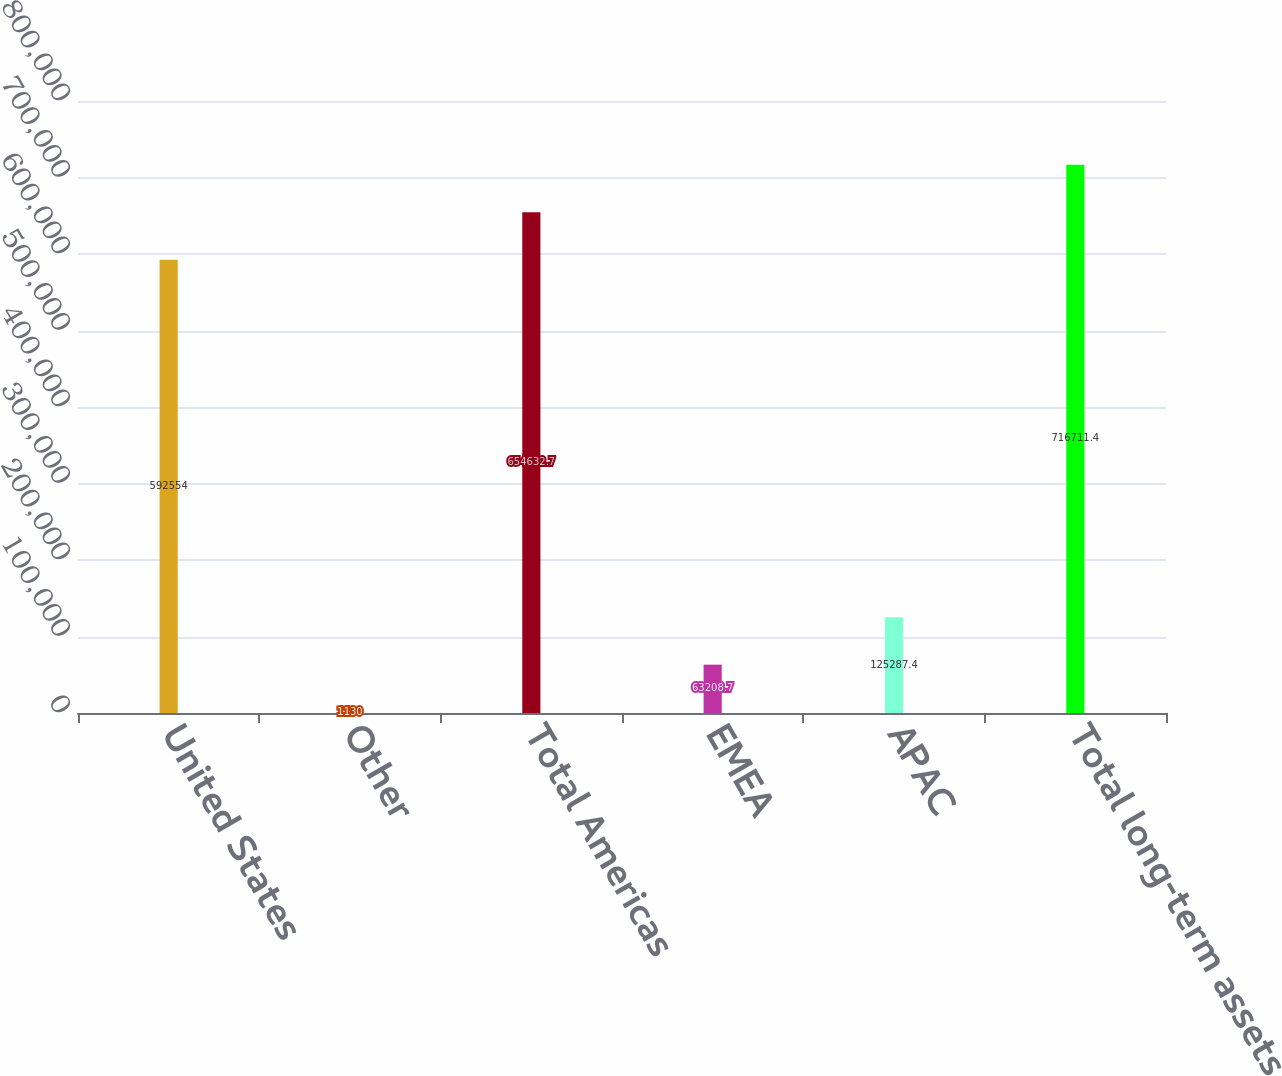Convert chart to OTSL. <chart><loc_0><loc_0><loc_500><loc_500><bar_chart><fcel>United States<fcel>Other<fcel>Total Americas<fcel>EMEA<fcel>APAC<fcel>Total long-term assets<nl><fcel>592554<fcel>1130<fcel>654633<fcel>63208.7<fcel>125287<fcel>716711<nl></chart> 